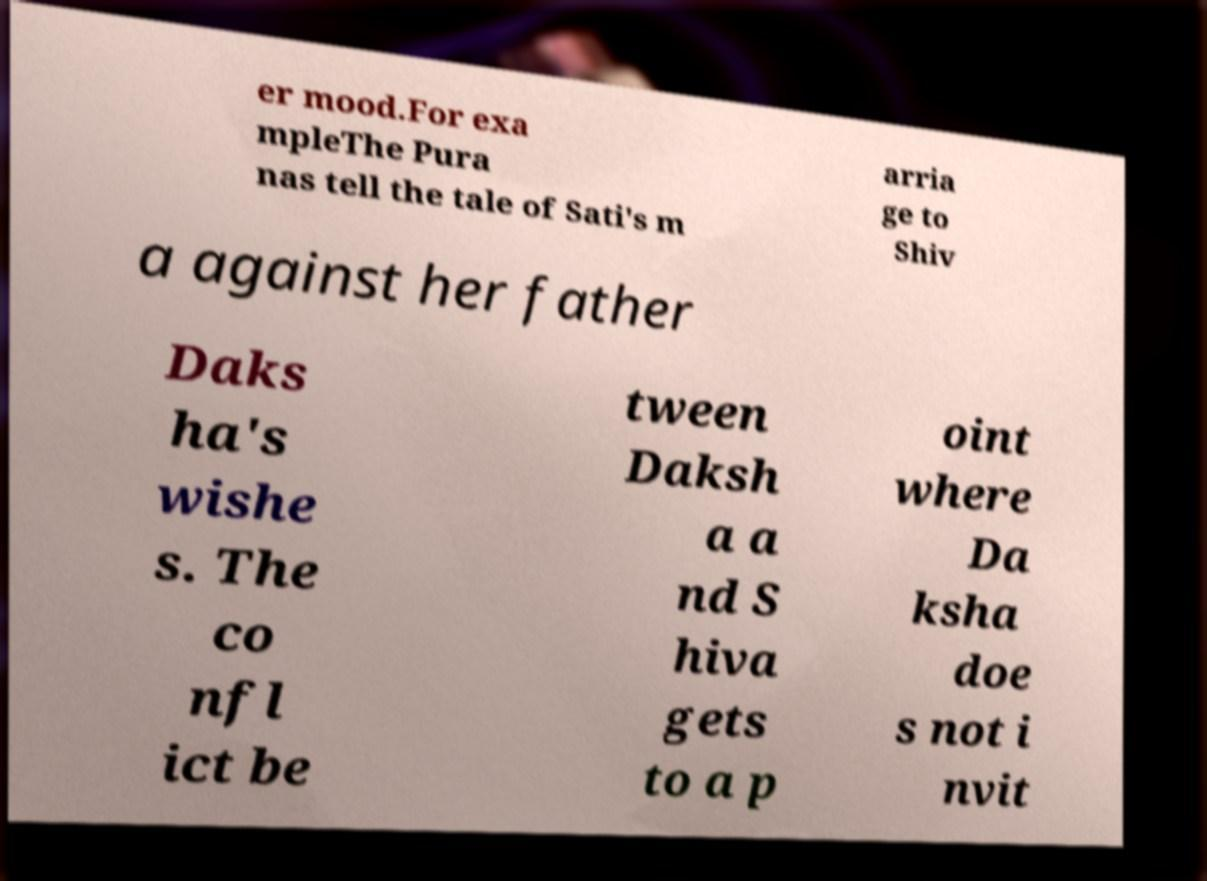I need the written content from this picture converted into text. Can you do that? er mood.For exa mpleThe Pura nas tell the tale of Sati's m arria ge to Shiv a against her father Daks ha's wishe s. The co nfl ict be tween Daksh a a nd S hiva gets to a p oint where Da ksha doe s not i nvit 